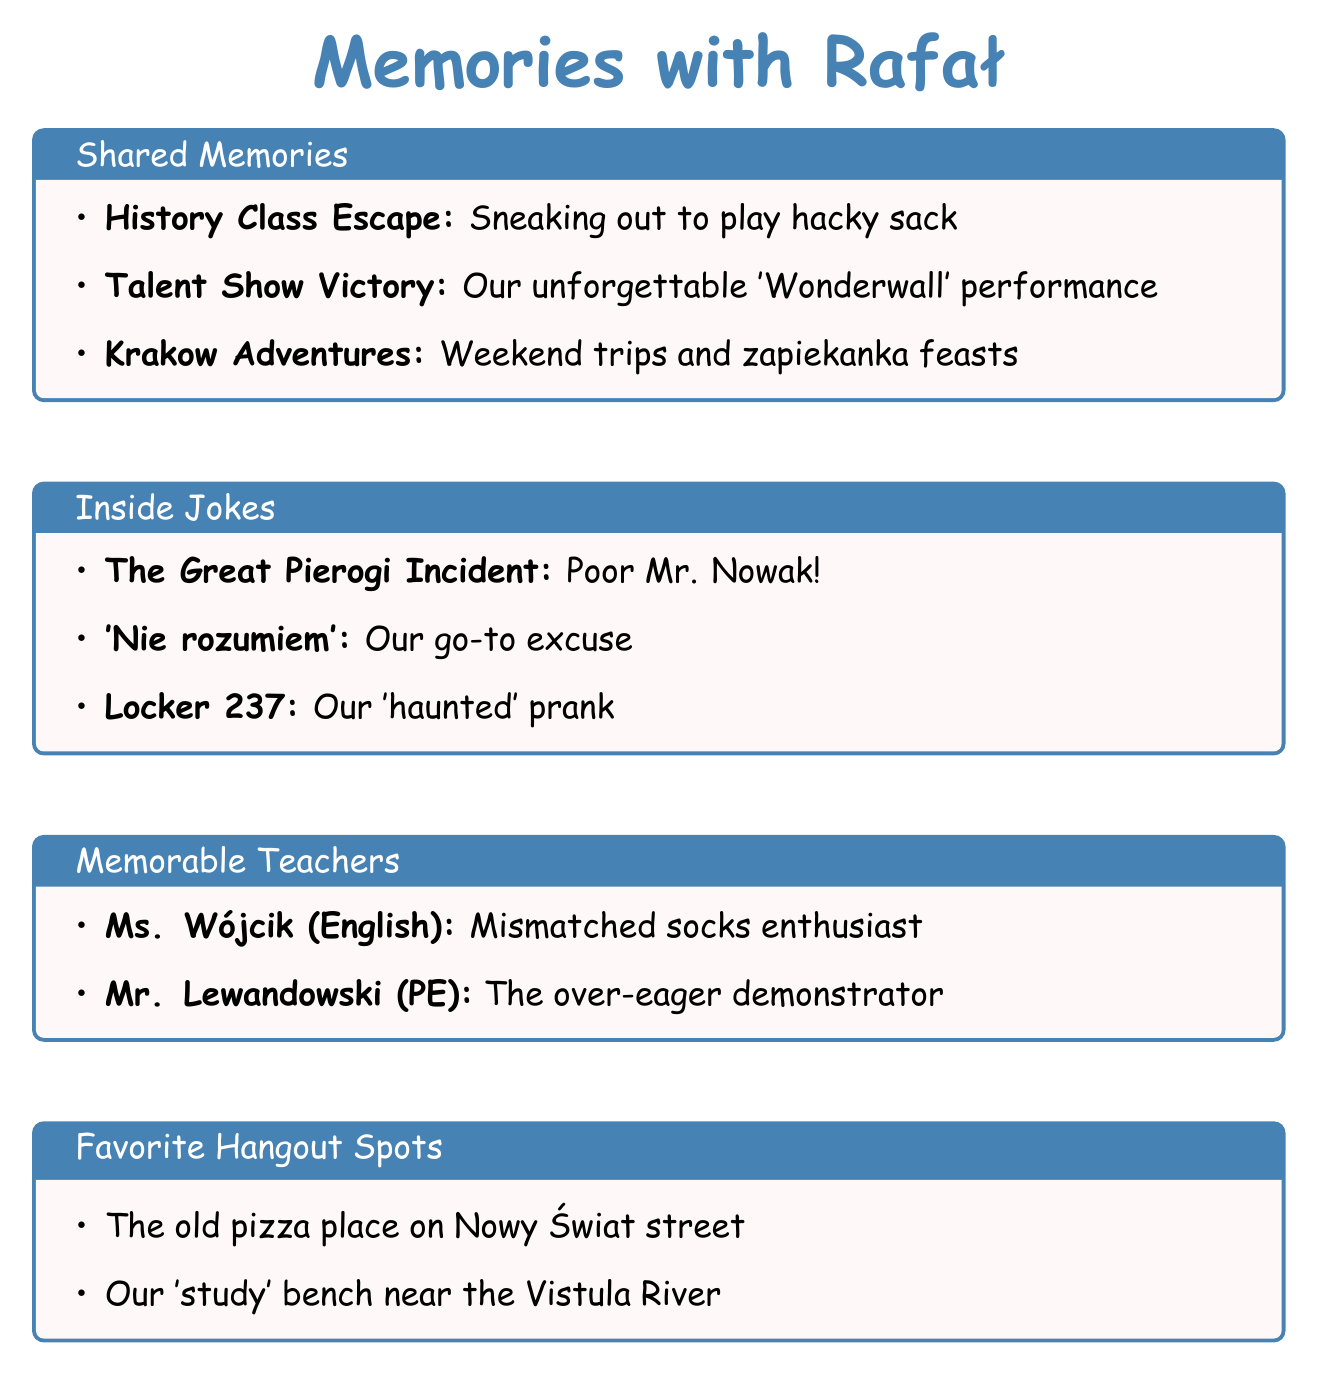What was the incident involving Mr. Nowak? The document mentions "The Great Pierogi Incident," where Rafał spilled a plate of pierogis on Mr. Nowak during the school festival.
Answer: The Great Pierogi Incident Who performed at the talent show? The document states that Rafał played guitar while another person sang.
Answer: Rafał What is one of the favorite hangout spots? The document lists "The old pizza place on Nowy Świat street" as a favorite hangout.
Answer: The old pizza place on Nowy Świat street What was Rafał's talent during the school talent show? The document specifies that Rafał played guitar during their performance.
Answer: Guitar What did they exaggerate when saying they didn't understand something? The document mentions they exaggerated an accent when saying "'Nie rozumiem'."
Answer: 'Nie rozumiem' Which teacher is noted for wearing mismatched socks? The document identifies Ms. Wójcik, who taught English, as wearing mismatched socks.
Answer: Ms. Wójcik In what city did they go on weekend trips? The document indicates they took trips to Krakow on weekends.
Answer: Krakow What subject did Mr. Lewandowski teach? The document specifies that Mr. Lewandowski taught Physical Education.
Answer: Physical Education What was the ghost story about? The document mentions that locker number 237 was believed to be haunted by a ghost.
Answer: Locker number 237 